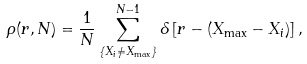<formula> <loc_0><loc_0><loc_500><loc_500>\rho ( r , N ) = \frac { 1 } { N } \sum _ { \{ X _ { i } \neq X _ { \max } \} } ^ { N - 1 } \delta \left [ r - ( X _ { \max } - X _ { i } ) \right ] ,</formula> 